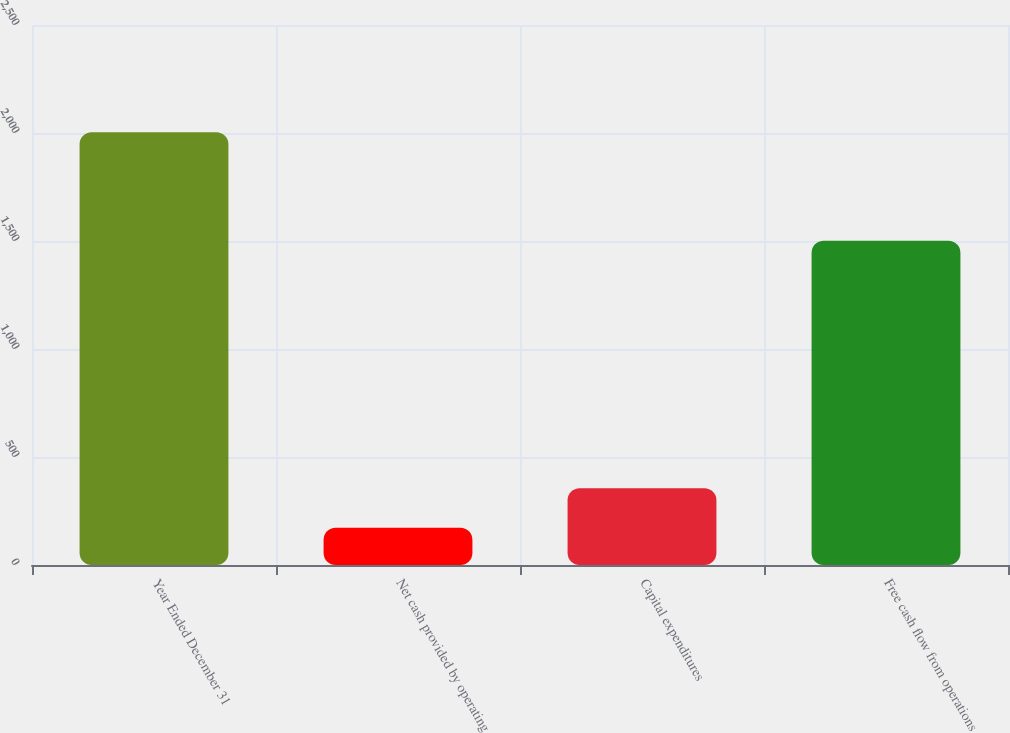<chart> <loc_0><loc_0><loc_500><loc_500><bar_chart><fcel>Year Ended December 31<fcel>Net cash provided by operating<fcel>Capital expenditures<fcel>Free cash flow from operations<nl><fcel>2003<fcel>172<fcel>355.1<fcel>1501<nl></chart> 